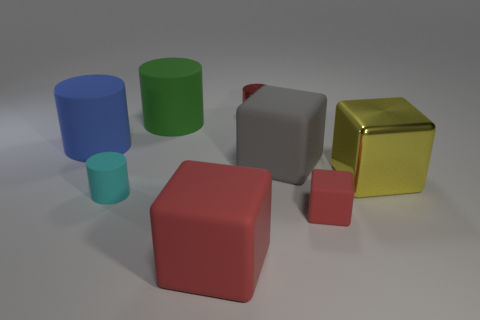Add 1 tiny green metal cylinders. How many objects exist? 9 Subtract all cyan matte cylinders. How many cylinders are left? 3 Subtract all green cylinders. Subtract all gray cubes. How many cylinders are left? 3 Subtract all green blocks. How many brown cylinders are left? 0 Subtract all rubber cylinders. Subtract all big cyan cylinders. How many objects are left? 5 Add 7 big rubber cylinders. How many big rubber cylinders are left? 9 Add 8 tiny yellow metallic blocks. How many tiny yellow metallic blocks exist? 8 Subtract all gray blocks. How many blocks are left? 3 Subtract 1 yellow cubes. How many objects are left? 7 Subtract 1 cylinders. How many cylinders are left? 3 